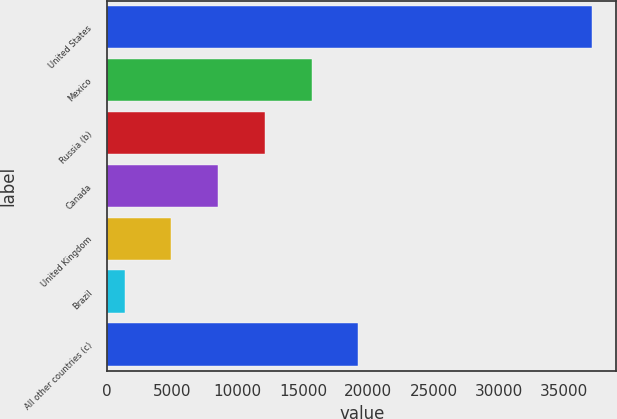Convert chart to OTSL. <chart><loc_0><loc_0><loc_500><loc_500><bar_chart><fcel>United States<fcel>Mexico<fcel>Russia (b)<fcel>Canada<fcel>United Kingdom<fcel>Brazil<fcel>All other countries (c)<nl><fcel>37148<fcel>15660.2<fcel>12078.9<fcel>8497.6<fcel>4916.3<fcel>1335<fcel>19241.5<nl></chart> 